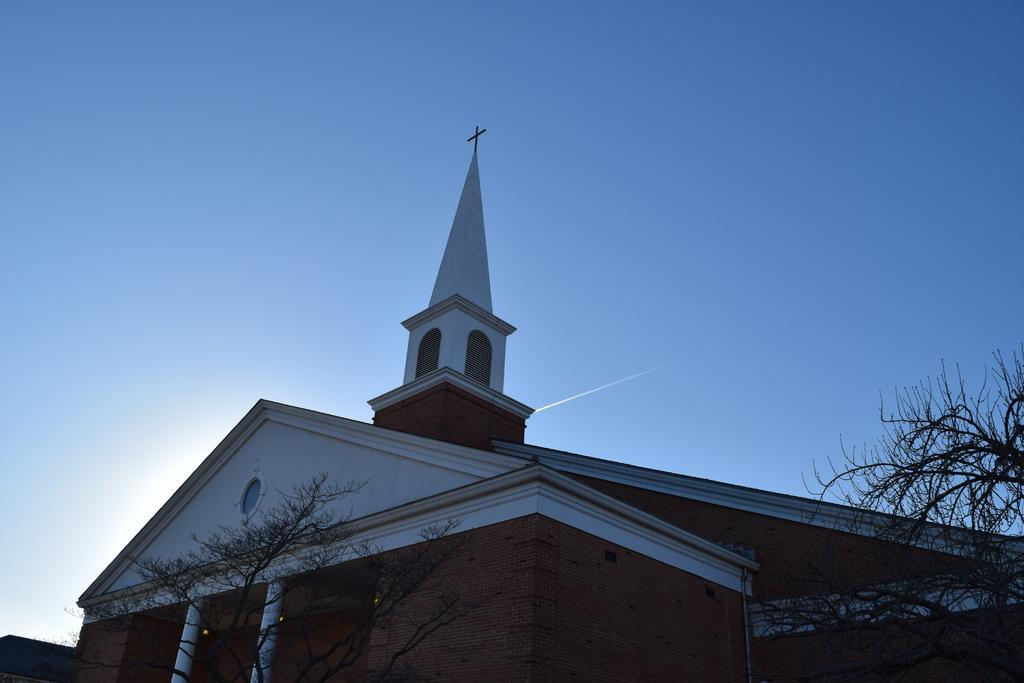What type of building is depicted in the image? There is a building with a cross on top in the image. Are there any other structures or objects near the building? Yes, there are trees beside the building in the image. What type of nail is being used to hold the jelly in place on the plough in the image? There is no nail, jelly, or plough present in the image. 